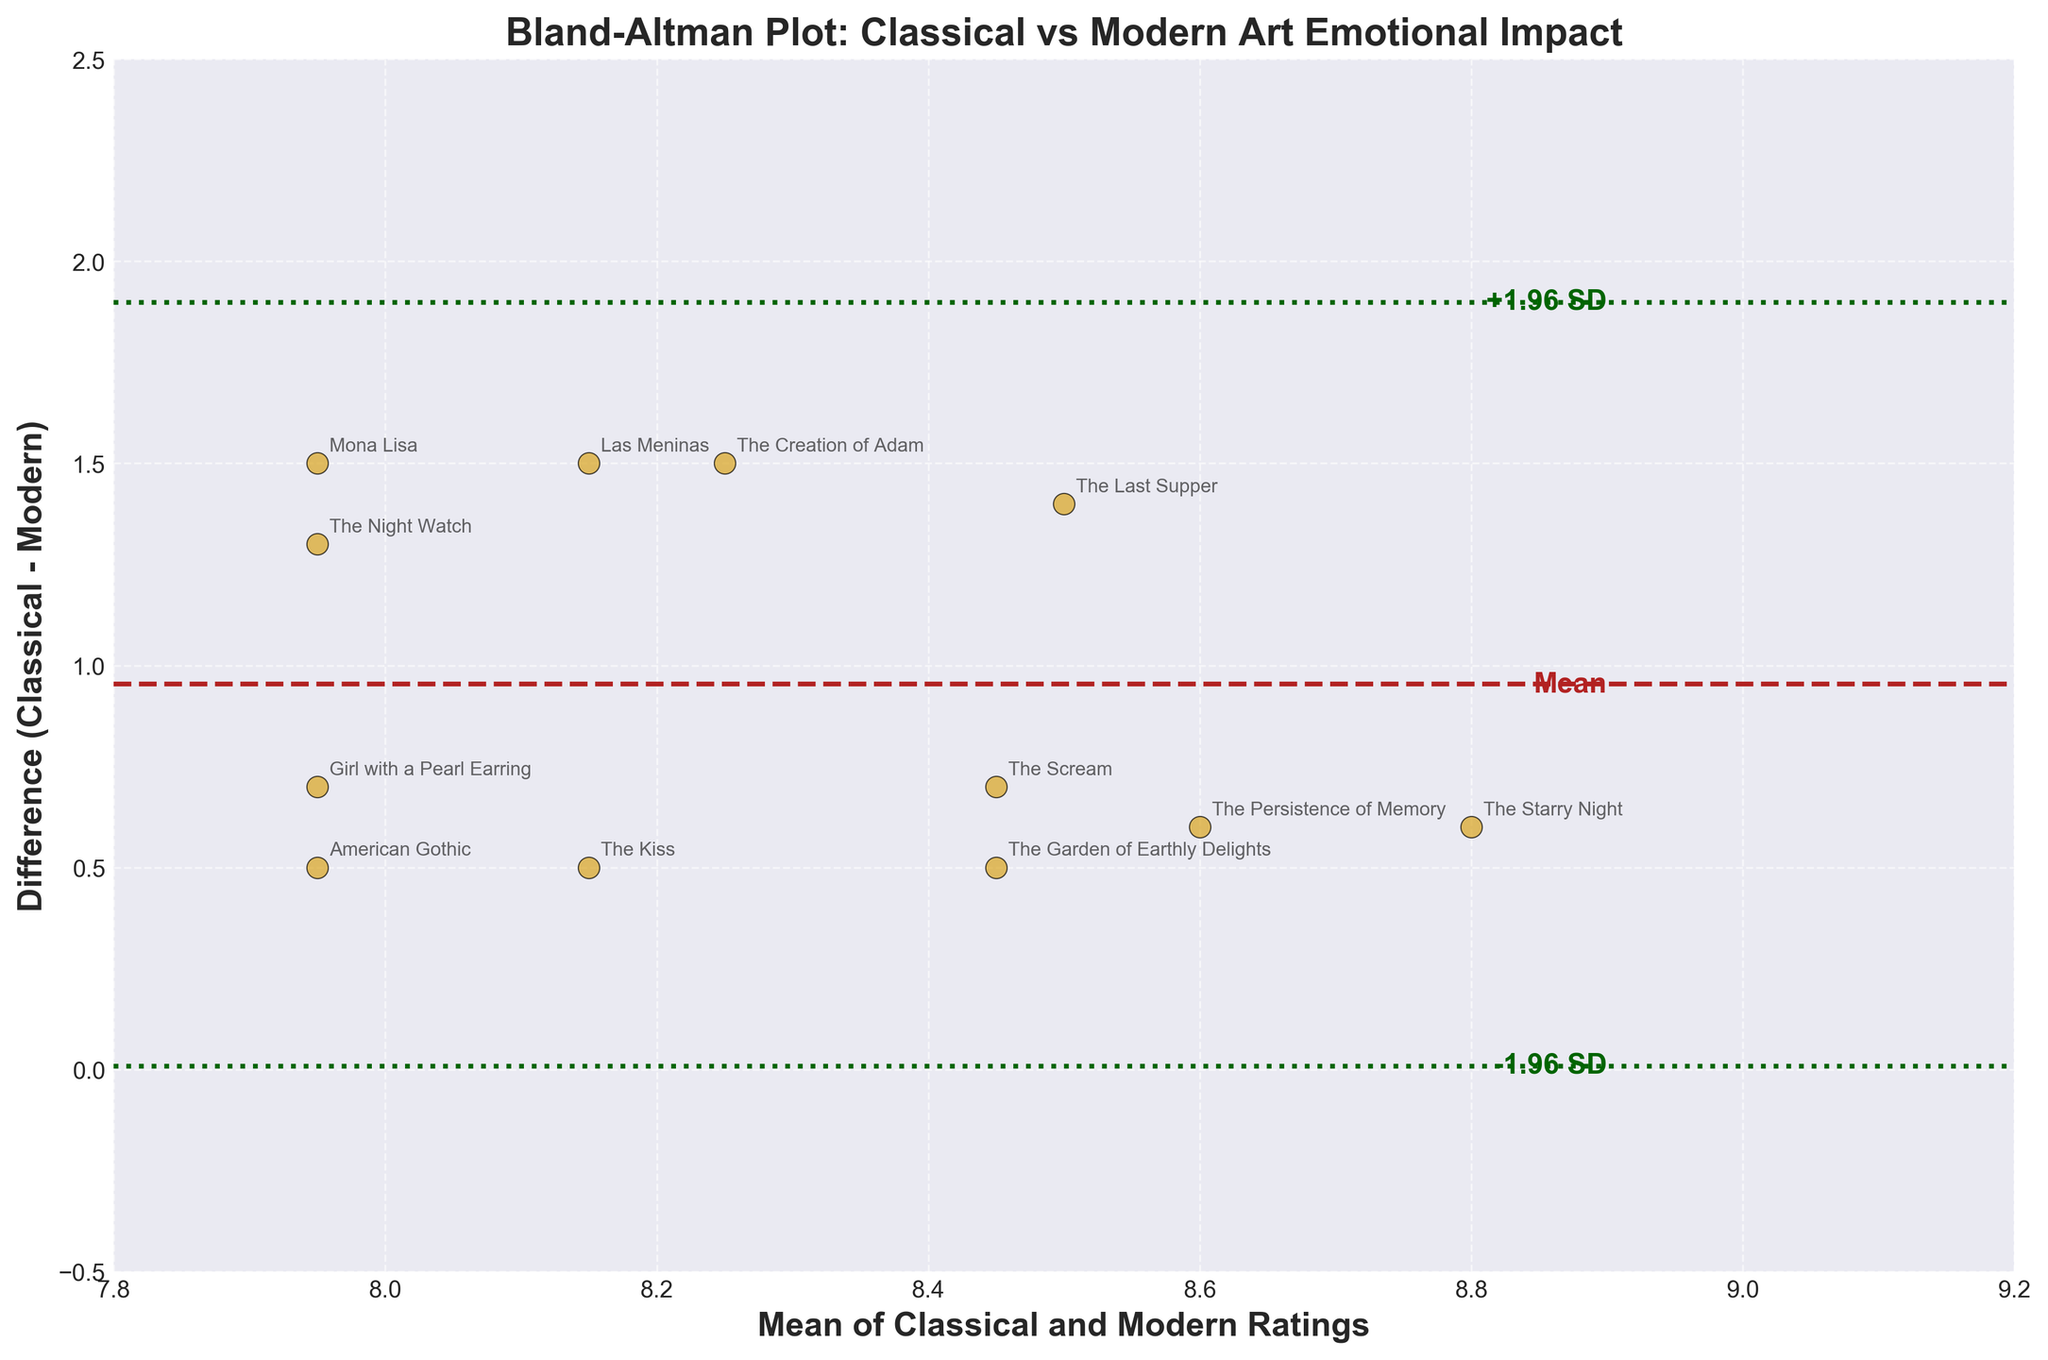What is the title of the plot? The title of the plot is written at the top of the figure and indicates the main theme or subject of the chart.
Answer: Bland-Altman Plot: Classical vs Modern Art Emotional Impact How many data points are represented in the plot? The number of data points can be determined by counting the number of scatter points on the figure.
Answer: 15 What does the x-axis represent? The label of the x-axis describes what the horizontal axis measures, which is found below the x-axis line.
Answer: Mean of Classical and Modern Ratings What are the colors used for the scatter points and the horizontal lines? The colors used for the scatter points and horizontal lines can be observed by looking at the plot's visual elements.
Answer: Goldenrod, Firebrick, Dark Green What is the mean difference between classical and modern ratings? The mean difference is indicated by the horizontal dashed line in the middle of the plot and is also labeled as "Mean."
Answer: Roughly 1.2 What are the limits of agreement in the plot? The limits of agreement can be identified by the two horizontal dotted lines labeled as "-1.96 SD" and "+1.96 SD."
Answer: Roughly -0.1 and 2.5 Which artwork has the largest positive difference between classical and modern ratings? Finding the data point farthest above the mean difference line reveals the artwork with the largest positive difference.
Answer: The Birth of Venus Which artwork has ratings that are closest to each other? The artwork with the smallest vertical distance from the x-axis indicates the closest ratings.
Answer: The Son of Man What is the difference between ratings for 'The Creation of Adam'? The vertical position of the data point labeled 'The Creation of Adam' on the y-axis indicates the difference in ratings.
Answer: Roughly 1.5 Are there any artworks where the modern rating exceeds the classical rating? To determine this, look for any points below the zero marker on the y-axis, indicating a negative difference.
Answer: None 